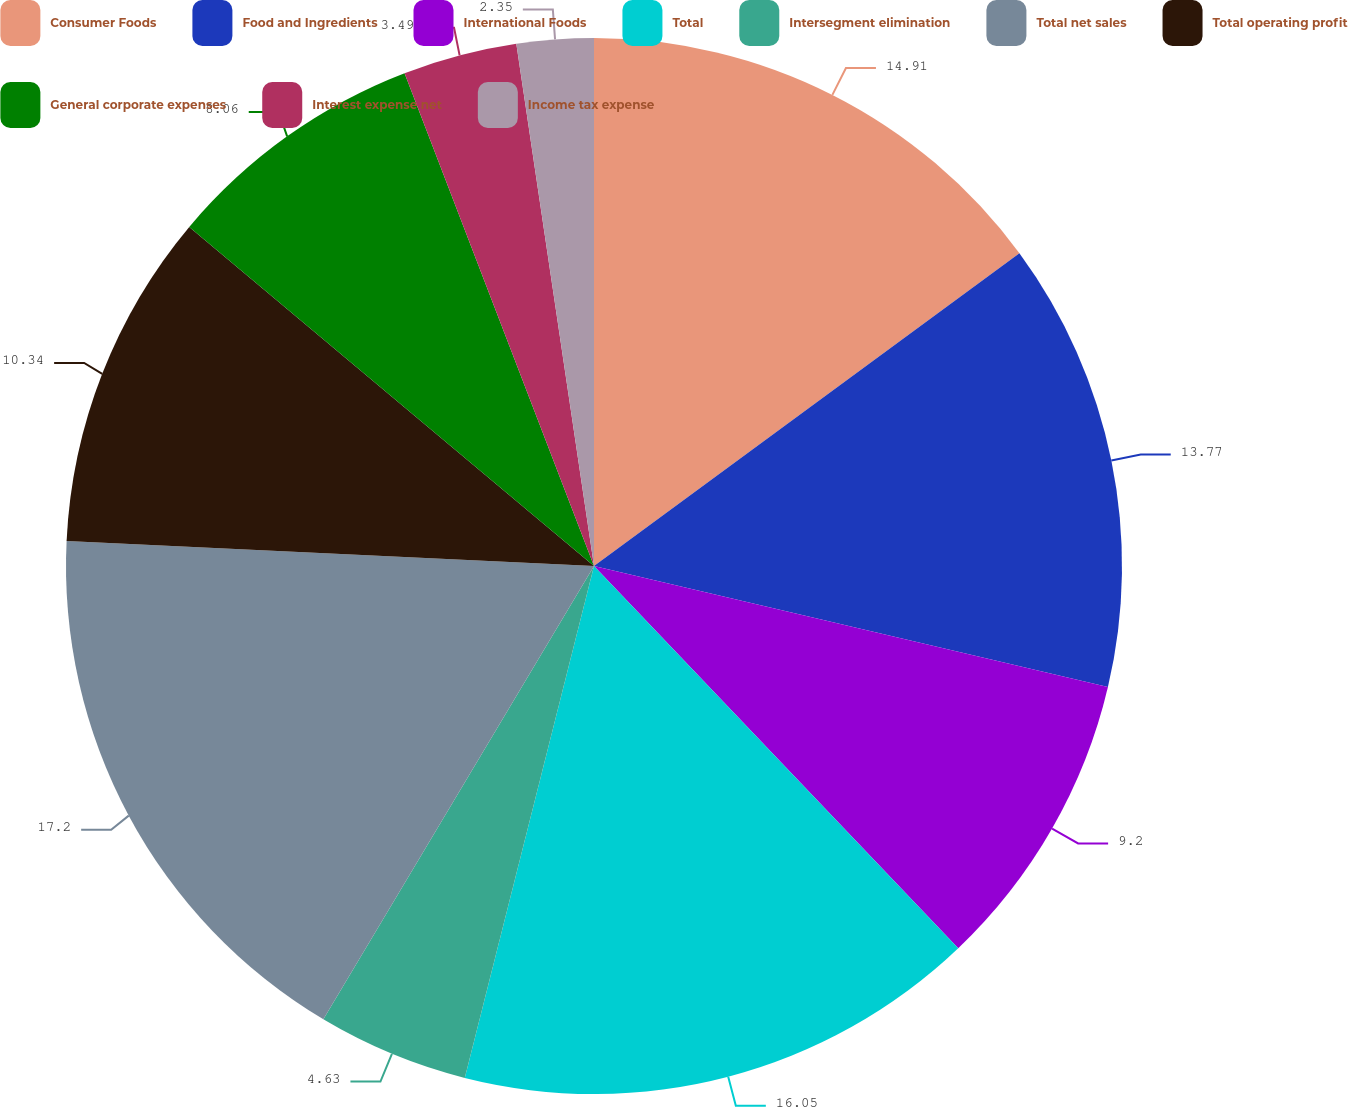<chart> <loc_0><loc_0><loc_500><loc_500><pie_chart><fcel>Consumer Foods<fcel>Food and Ingredients<fcel>International Foods<fcel>Total<fcel>Intersegment elimination<fcel>Total net sales<fcel>Total operating profit<fcel>General corporate expenses<fcel>Interest expense net<fcel>Income tax expense<nl><fcel>14.91%<fcel>13.77%<fcel>9.2%<fcel>16.05%<fcel>4.63%<fcel>17.19%<fcel>10.34%<fcel>8.06%<fcel>3.49%<fcel>2.35%<nl></chart> 